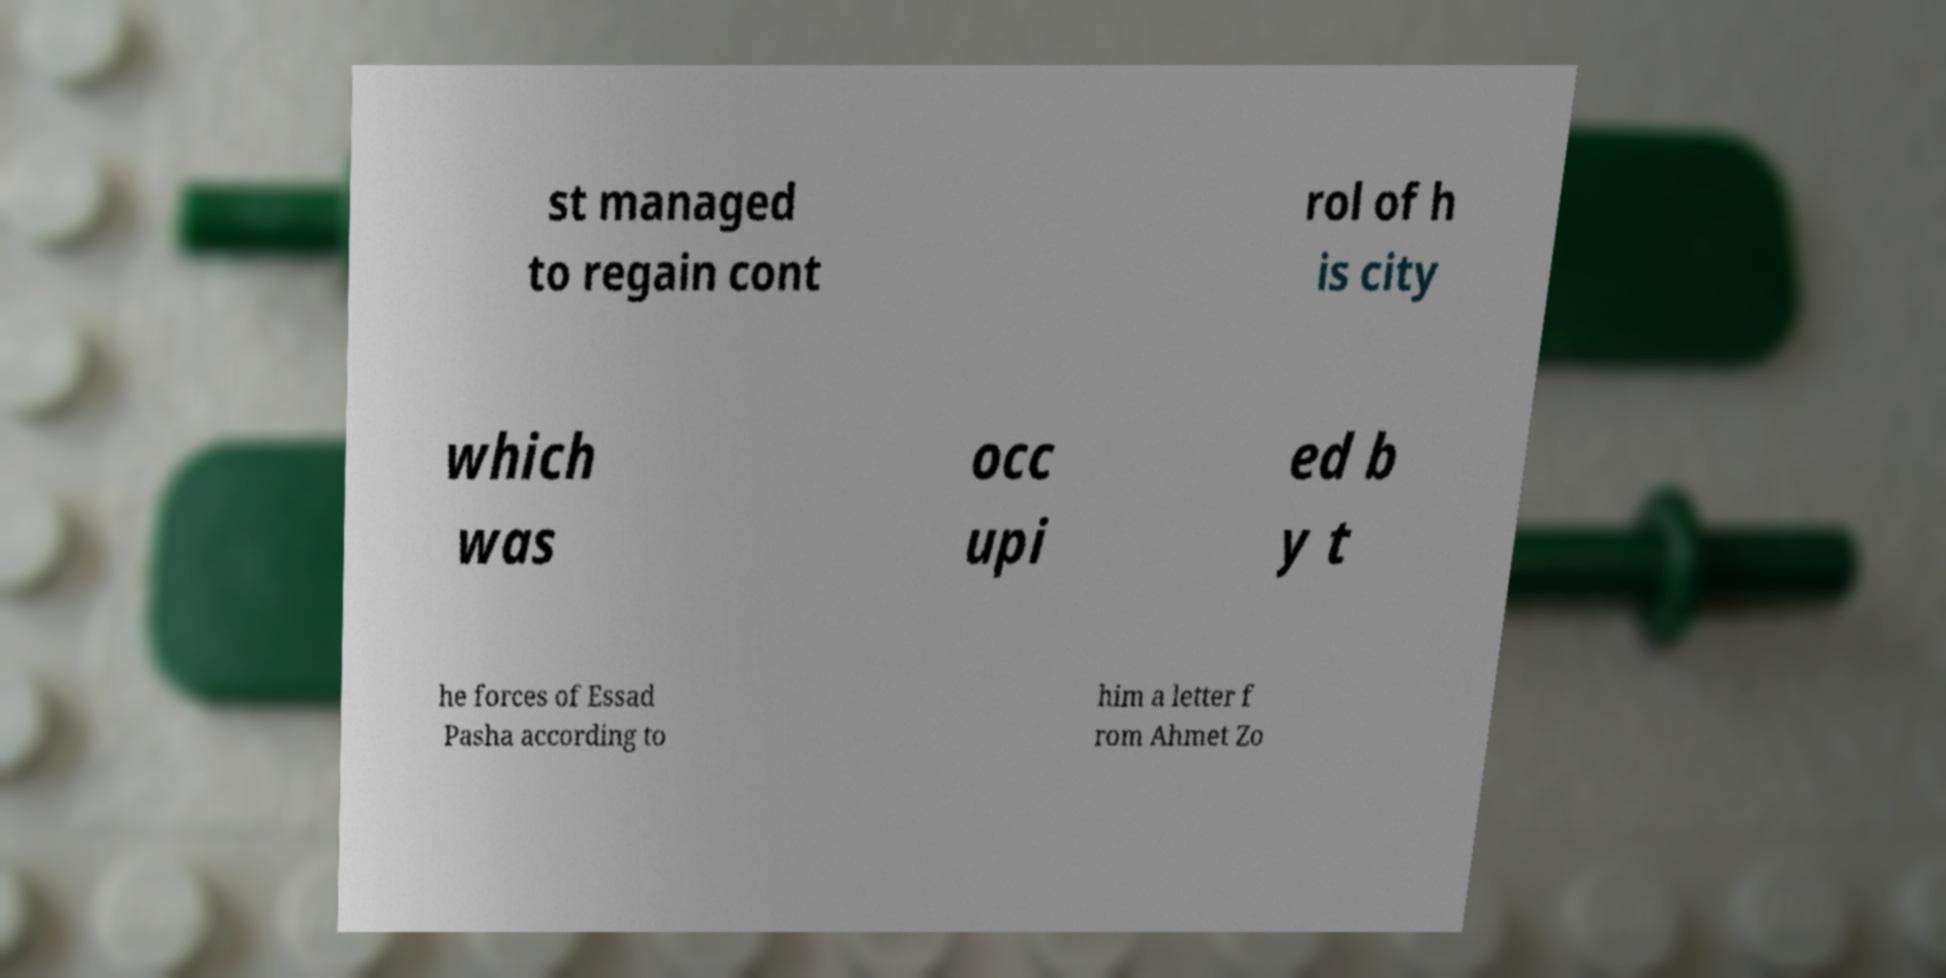Please read and relay the text visible in this image. What does it say? st managed to regain cont rol of h is city which was occ upi ed b y t he forces of Essad Pasha according to him a letter f rom Ahmet Zo 